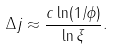Convert formula to latex. <formula><loc_0><loc_0><loc_500><loc_500>\Delta j \approx \frac { c \ln ( 1 / \phi ) } { \ln \xi } .</formula> 